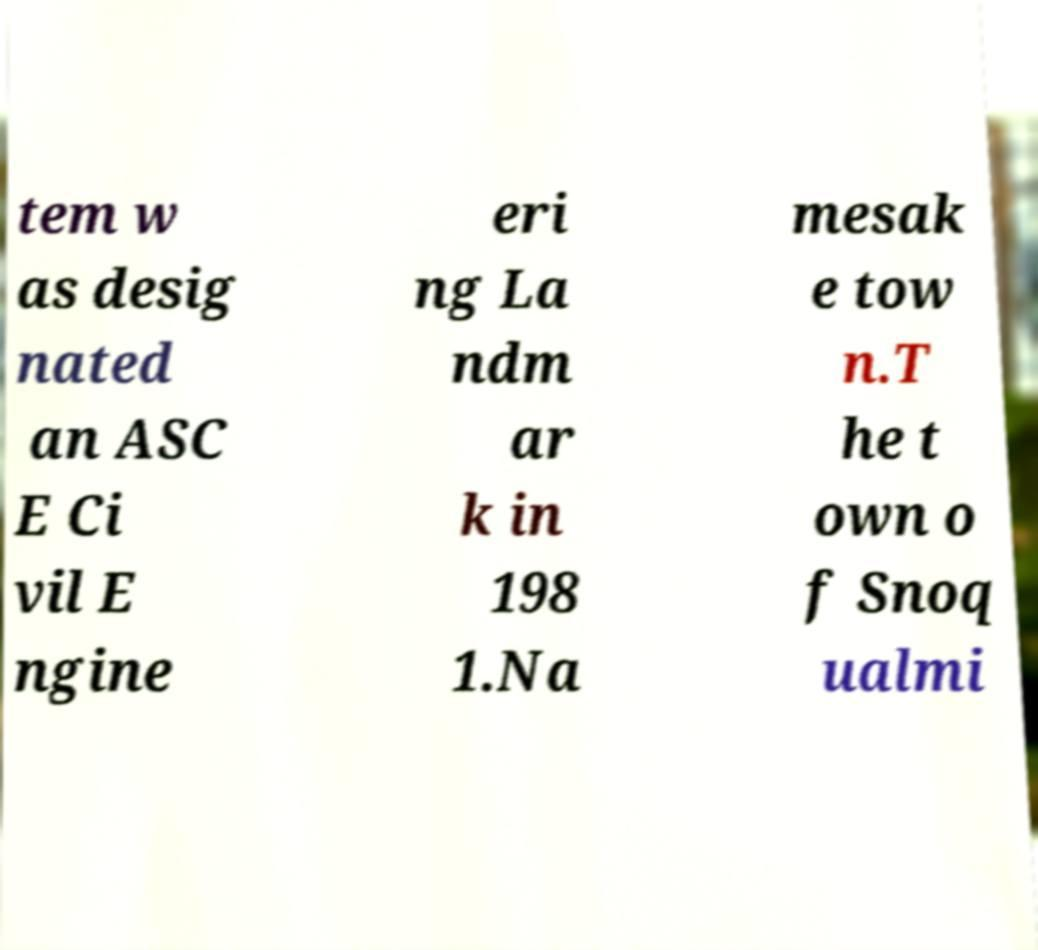There's text embedded in this image that I need extracted. Can you transcribe it verbatim? tem w as desig nated an ASC E Ci vil E ngine eri ng La ndm ar k in 198 1.Na mesak e tow n.T he t own o f Snoq ualmi 